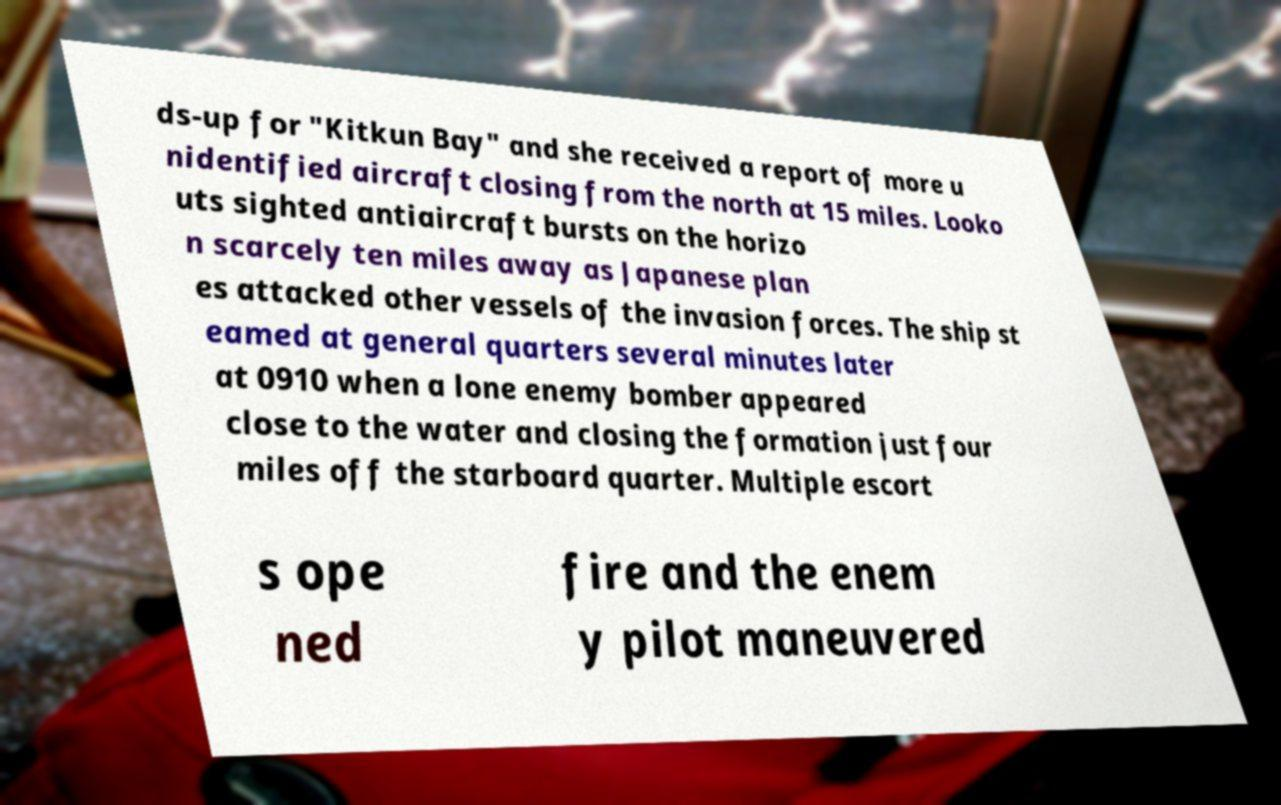Could you extract and type out the text from this image? ds-up for "Kitkun Bay" and she received a report of more u nidentified aircraft closing from the north at 15 miles. Looko uts sighted antiaircraft bursts on the horizo n scarcely ten miles away as Japanese plan es attacked other vessels of the invasion forces. The ship st eamed at general quarters several minutes later at 0910 when a lone enemy bomber appeared close to the water and closing the formation just four miles off the starboard quarter. Multiple escort s ope ned fire and the enem y pilot maneuvered 